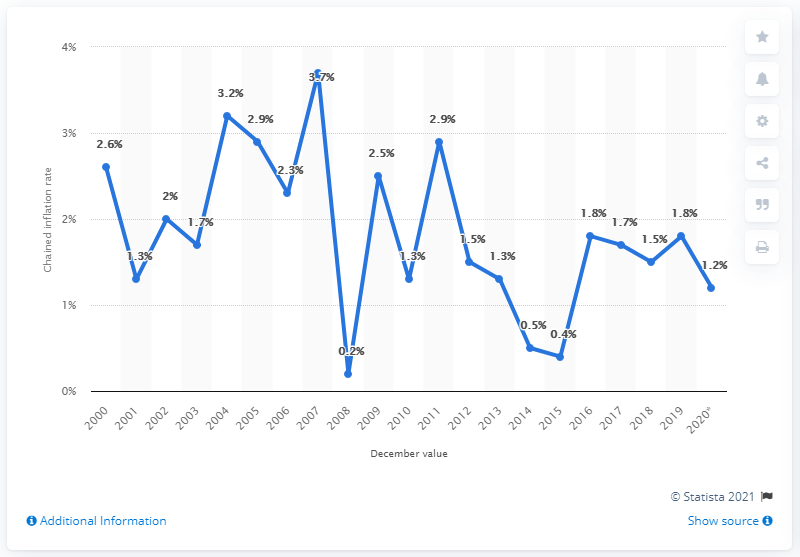Give some essential details in this illustration. In December 2020, the prices increased by 1.2 times compared to December 2019. 